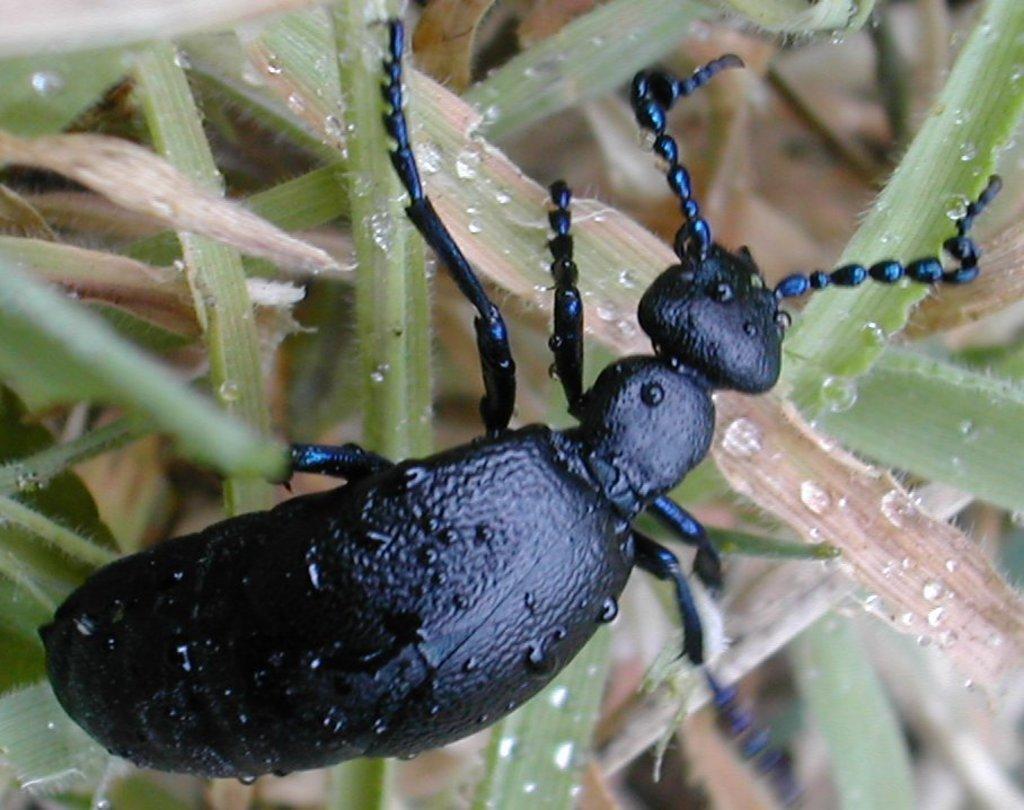Can you describe this image briefly? In this image we can see an insect on the plants. 